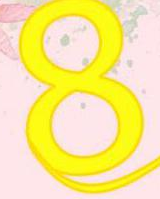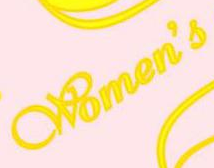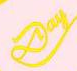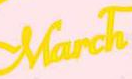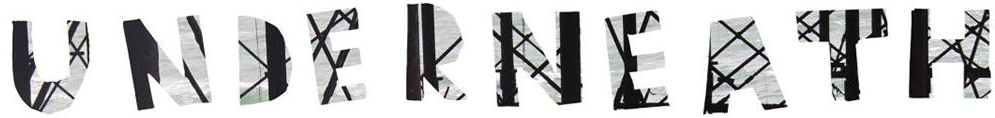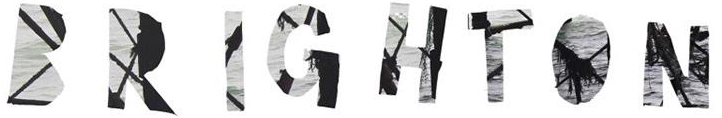What text appears in these images from left to right, separated by a semicolon? 8; Women's; Day; March; UNDERNEATH; BRIGHTON 